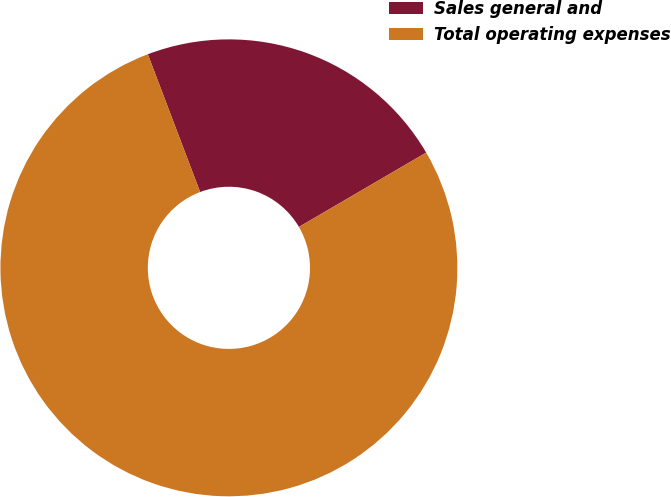Convert chart to OTSL. <chart><loc_0><loc_0><loc_500><loc_500><pie_chart><fcel>Sales general and<fcel>Total operating expenses<nl><fcel>22.36%<fcel>77.64%<nl></chart> 